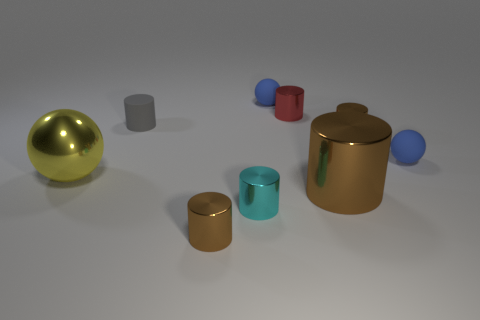Are the big thing that is right of the large shiny ball and the gray cylinder made of the same material?
Give a very brief answer. No. What is the large brown object in front of the small blue thing that is behind the tiny gray cylinder made of?
Keep it short and to the point. Metal. What number of other shiny objects have the same shape as the tiny cyan thing?
Your response must be concise. 4. There is a brown metallic cylinder behind the tiny ball in front of the tiny cylinder behind the small gray thing; how big is it?
Give a very brief answer. Small. How many red things are big objects or shiny things?
Ensure brevity in your answer.  1. There is a big shiny object that is in front of the big yellow object; does it have the same shape as the tiny gray object?
Provide a succinct answer. Yes. Is the number of blue matte spheres in front of the gray object greater than the number of tiny cubes?
Provide a succinct answer. Yes. How many metallic objects are the same size as the cyan metallic cylinder?
Offer a terse response. 3. What number of things are either small red metal cylinders or small cylinders in front of the large sphere?
Offer a very short reply. 3. What color is the tiny metal thing that is both behind the large brown thing and in front of the gray thing?
Your response must be concise. Brown. 